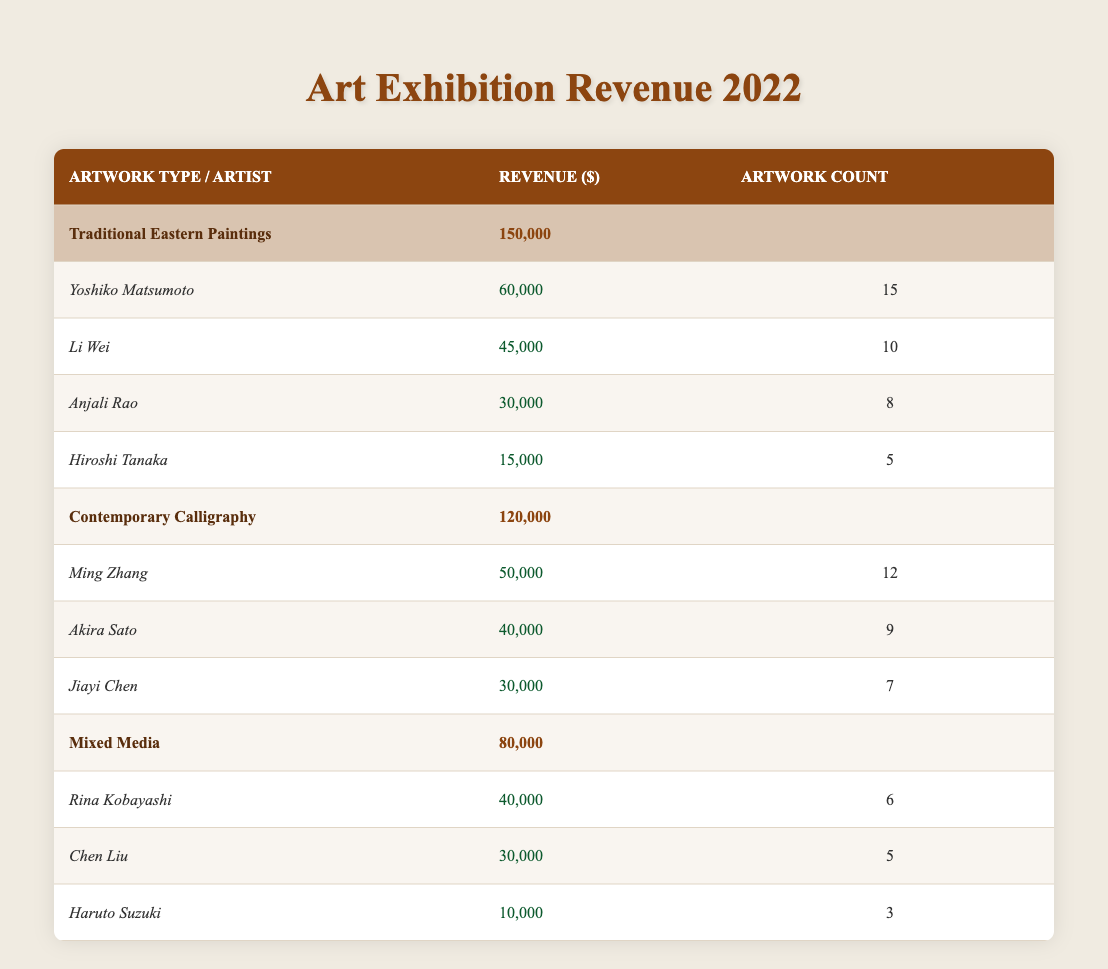What is the total revenue from Traditional Eastern Paintings? The table shows that the total revenue for Traditional Eastern Paintings is listed under the relevant section. It indicates a total of 150000.
Answer: 150000 Which artist generated the highest revenue from Contemporary Calligraphy? By reviewing the Contemporary Calligraphy section, Ming Zhang has the highest revenue, which is 50000.
Answer: Ming Zhang How many artworks did Li Wei create? Looking in the Traditional Eastern Paintings section, Li Wei's artwork count is specified as 10.
Answer: 10 What is the combined revenue of all artists in the Mixed Media category? The revenue for Mixed Media artists is: Rina Kobayashi (40000) + Chen Liu (30000) + Haruto Suzuki (10000), totaling 80000 for the category.
Answer: 80000 Is the total revenue from Contemporary Calligraphy greater than that from Traditional Eastern Paintings? The total revenue for Contemporary Calligraphy is 120000, and for Traditional Eastern Paintings, it is 150000. Since 120000 is less than 150000, the statement is false.
Answer: No What is the average revenue per artwork for Yoshiko Matsumoto? Yoshiko Matsumoto generated 60000 from 15 artworks. To find the average revenue, divide 60000 by 15, resulting in an average of 4000 per artwork.
Answer: 4000 How many more artworks did Akira Sato create compared to Jiayi Chen? Akira Sato's artwork count is 9 and Jiayi Chen's is 7. The difference is 9 - 7, which equals 2 more artworks created by Akira Sato.
Answer: 2 Which type of artwork generated the least revenue in total? The revenue totals indicate that Mixed Media generated 80000, which is less than both Traditional Eastern Paintings (150000) and Contemporary Calligraphy (120000), making it the least.
Answer: Mixed Media What is the total number of artworks from all artists in the Traditional Eastern Paintings category? By adding the artwork count: 15 + 10 + 8 + 5 for Yoshiko Matsumoto, Li Wei, Anjali Rao, and Hiroshi Tanaka respectively, the total is 38.
Answer: 38 